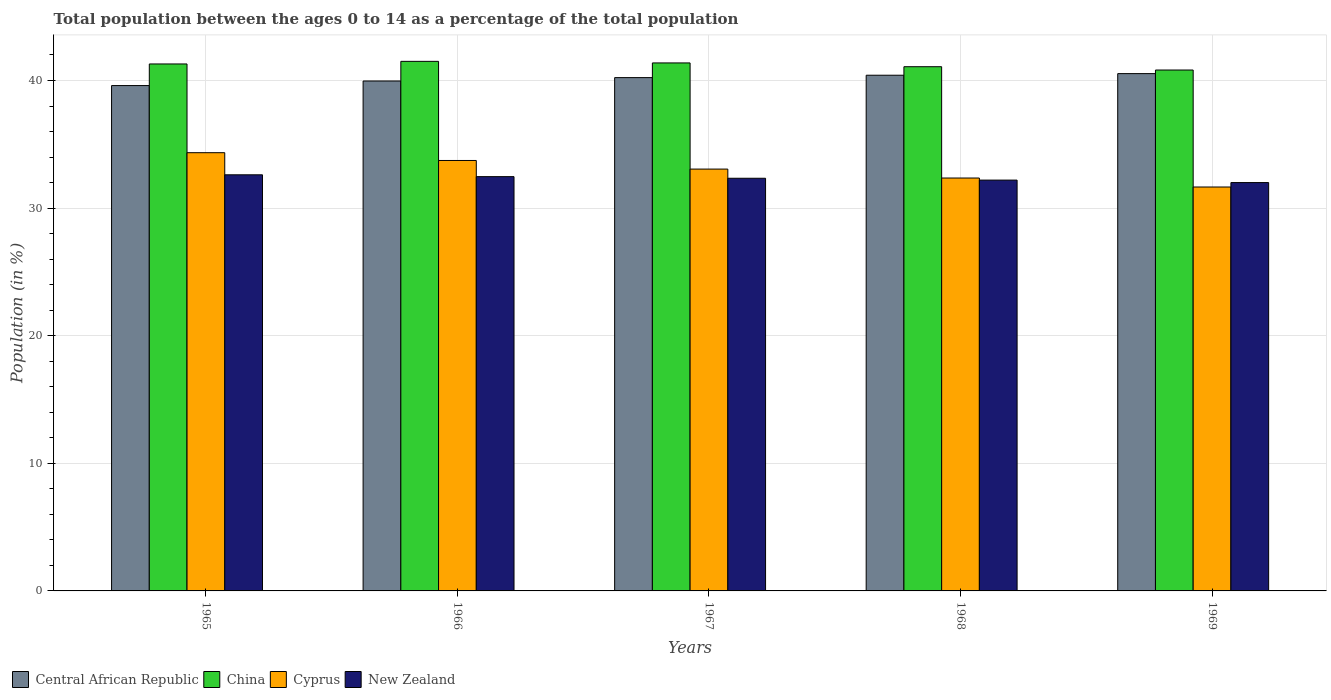Are the number of bars per tick equal to the number of legend labels?
Offer a terse response. Yes. Are the number of bars on each tick of the X-axis equal?
Provide a succinct answer. Yes. How many bars are there on the 2nd tick from the left?
Your response must be concise. 4. What is the label of the 3rd group of bars from the left?
Give a very brief answer. 1967. In how many cases, is the number of bars for a given year not equal to the number of legend labels?
Make the answer very short. 0. What is the percentage of the population ages 0 to 14 in China in 1968?
Your answer should be compact. 41.08. Across all years, what is the maximum percentage of the population ages 0 to 14 in Central African Republic?
Ensure brevity in your answer.  40.54. Across all years, what is the minimum percentage of the population ages 0 to 14 in Cyprus?
Your response must be concise. 31.65. In which year was the percentage of the population ages 0 to 14 in New Zealand maximum?
Keep it short and to the point. 1965. In which year was the percentage of the population ages 0 to 14 in Central African Republic minimum?
Keep it short and to the point. 1965. What is the total percentage of the population ages 0 to 14 in Central African Republic in the graph?
Provide a short and direct response. 200.74. What is the difference between the percentage of the population ages 0 to 14 in Cyprus in 1967 and that in 1968?
Ensure brevity in your answer.  0.7. What is the difference between the percentage of the population ages 0 to 14 in Cyprus in 1968 and the percentage of the population ages 0 to 14 in New Zealand in 1967?
Your response must be concise. 0.02. What is the average percentage of the population ages 0 to 14 in China per year?
Offer a very short reply. 41.22. In the year 1965, what is the difference between the percentage of the population ages 0 to 14 in New Zealand and percentage of the population ages 0 to 14 in Central African Republic?
Your response must be concise. -6.99. What is the ratio of the percentage of the population ages 0 to 14 in Cyprus in 1968 to that in 1969?
Ensure brevity in your answer.  1.02. Is the percentage of the population ages 0 to 14 in Central African Republic in 1966 less than that in 1969?
Offer a terse response. Yes. Is the difference between the percentage of the population ages 0 to 14 in New Zealand in 1966 and 1968 greater than the difference between the percentage of the population ages 0 to 14 in Central African Republic in 1966 and 1968?
Your response must be concise. Yes. What is the difference between the highest and the second highest percentage of the population ages 0 to 14 in Central African Republic?
Keep it short and to the point. 0.13. What is the difference between the highest and the lowest percentage of the population ages 0 to 14 in New Zealand?
Ensure brevity in your answer.  0.61. In how many years, is the percentage of the population ages 0 to 14 in Central African Republic greater than the average percentage of the population ages 0 to 14 in Central African Republic taken over all years?
Provide a short and direct response. 3. What does the 4th bar from the left in 1965 represents?
Ensure brevity in your answer.  New Zealand. What does the 4th bar from the right in 1967 represents?
Your answer should be very brief. Central African Republic. Is it the case that in every year, the sum of the percentage of the population ages 0 to 14 in Cyprus and percentage of the population ages 0 to 14 in New Zealand is greater than the percentage of the population ages 0 to 14 in China?
Your response must be concise. Yes. Are all the bars in the graph horizontal?
Your response must be concise. No. How many years are there in the graph?
Give a very brief answer. 5. What is the difference between two consecutive major ticks on the Y-axis?
Offer a terse response. 10. How many legend labels are there?
Keep it short and to the point. 4. How are the legend labels stacked?
Offer a very short reply. Horizontal. What is the title of the graph?
Make the answer very short. Total population between the ages 0 to 14 as a percentage of the total population. Does "Zambia" appear as one of the legend labels in the graph?
Your response must be concise. No. What is the label or title of the X-axis?
Make the answer very short. Years. What is the Population (in %) of Central African Republic in 1965?
Your answer should be compact. 39.6. What is the Population (in %) of China in 1965?
Your answer should be very brief. 41.3. What is the Population (in %) of Cyprus in 1965?
Offer a very short reply. 34.34. What is the Population (in %) in New Zealand in 1965?
Offer a terse response. 32.61. What is the Population (in %) of Central African Republic in 1966?
Make the answer very short. 39.96. What is the Population (in %) in China in 1966?
Make the answer very short. 41.5. What is the Population (in %) in Cyprus in 1966?
Keep it short and to the point. 33.73. What is the Population (in %) of New Zealand in 1966?
Your answer should be very brief. 32.47. What is the Population (in %) of Central African Republic in 1967?
Your answer should be very brief. 40.23. What is the Population (in %) in China in 1967?
Your response must be concise. 41.38. What is the Population (in %) in Cyprus in 1967?
Your answer should be compact. 33.06. What is the Population (in %) of New Zealand in 1967?
Provide a succinct answer. 32.34. What is the Population (in %) of Central African Republic in 1968?
Provide a succinct answer. 40.41. What is the Population (in %) in China in 1968?
Make the answer very short. 41.08. What is the Population (in %) of Cyprus in 1968?
Keep it short and to the point. 32.36. What is the Population (in %) in New Zealand in 1968?
Make the answer very short. 32.19. What is the Population (in %) of Central African Republic in 1969?
Your response must be concise. 40.54. What is the Population (in %) in China in 1969?
Your answer should be compact. 40.82. What is the Population (in %) of Cyprus in 1969?
Your response must be concise. 31.65. What is the Population (in %) in New Zealand in 1969?
Provide a short and direct response. 32. Across all years, what is the maximum Population (in %) of Central African Republic?
Your response must be concise. 40.54. Across all years, what is the maximum Population (in %) of China?
Make the answer very short. 41.5. Across all years, what is the maximum Population (in %) in Cyprus?
Offer a terse response. 34.34. Across all years, what is the maximum Population (in %) in New Zealand?
Offer a terse response. 32.61. Across all years, what is the minimum Population (in %) of Central African Republic?
Provide a short and direct response. 39.6. Across all years, what is the minimum Population (in %) in China?
Offer a terse response. 40.82. Across all years, what is the minimum Population (in %) of Cyprus?
Offer a terse response. 31.65. Across all years, what is the minimum Population (in %) in New Zealand?
Offer a terse response. 32. What is the total Population (in %) in Central African Republic in the graph?
Keep it short and to the point. 200.74. What is the total Population (in %) in China in the graph?
Your answer should be very brief. 206.08. What is the total Population (in %) of Cyprus in the graph?
Offer a terse response. 165.14. What is the total Population (in %) in New Zealand in the graph?
Your answer should be very brief. 161.61. What is the difference between the Population (in %) in Central African Republic in 1965 and that in 1966?
Your answer should be compact. -0.36. What is the difference between the Population (in %) in China in 1965 and that in 1966?
Offer a terse response. -0.2. What is the difference between the Population (in %) of Cyprus in 1965 and that in 1966?
Provide a short and direct response. 0.61. What is the difference between the Population (in %) in New Zealand in 1965 and that in 1966?
Give a very brief answer. 0.14. What is the difference between the Population (in %) of Central African Republic in 1965 and that in 1967?
Your answer should be compact. -0.62. What is the difference between the Population (in %) of China in 1965 and that in 1967?
Provide a short and direct response. -0.08. What is the difference between the Population (in %) in Cyprus in 1965 and that in 1967?
Offer a very short reply. 1.29. What is the difference between the Population (in %) in New Zealand in 1965 and that in 1967?
Provide a short and direct response. 0.27. What is the difference between the Population (in %) of Central African Republic in 1965 and that in 1968?
Provide a succinct answer. -0.81. What is the difference between the Population (in %) in China in 1965 and that in 1968?
Keep it short and to the point. 0.22. What is the difference between the Population (in %) of Cyprus in 1965 and that in 1968?
Your response must be concise. 1.99. What is the difference between the Population (in %) of New Zealand in 1965 and that in 1968?
Your answer should be very brief. 0.42. What is the difference between the Population (in %) in Central African Republic in 1965 and that in 1969?
Your answer should be very brief. -0.94. What is the difference between the Population (in %) of China in 1965 and that in 1969?
Offer a terse response. 0.48. What is the difference between the Population (in %) in Cyprus in 1965 and that in 1969?
Provide a short and direct response. 2.69. What is the difference between the Population (in %) of New Zealand in 1965 and that in 1969?
Your response must be concise. 0.61. What is the difference between the Population (in %) of Central African Republic in 1966 and that in 1967?
Offer a very short reply. -0.26. What is the difference between the Population (in %) in China in 1966 and that in 1967?
Give a very brief answer. 0.12. What is the difference between the Population (in %) of Cyprus in 1966 and that in 1967?
Your response must be concise. 0.68. What is the difference between the Population (in %) of New Zealand in 1966 and that in 1967?
Keep it short and to the point. 0.13. What is the difference between the Population (in %) of Central African Republic in 1966 and that in 1968?
Ensure brevity in your answer.  -0.45. What is the difference between the Population (in %) in China in 1966 and that in 1968?
Provide a succinct answer. 0.42. What is the difference between the Population (in %) of Cyprus in 1966 and that in 1968?
Make the answer very short. 1.38. What is the difference between the Population (in %) in New Zealand in 1966 and that in 1968?
Offer a very short reply. 0.27. What is the difference between the Population (in %) of Central African Republic in 1966 and that in 1969?
Offer a very short reply. -0.58. What is the difference between the Population (in %) of China in 1966 and that in 1969?
Your response must be concise. 0.68. What is the difference between the Population (in %) of Cyprus in 1966 and that in 1969?
Your answer should be very brief. 2.08. What is the difference between the Population (in %) of New Zealand in 1966 and that in 1969?
Your answer should be very brief. 0.46. What is the difference between the Population (in %) in Central African Republic in 1967 and that in 1968?
Your answer should be very brief. -0.19. What is the difference between the Population (in %) in China in 1967 and that in 1968?
Provide a short and direct response. 0.3. What is the difference between the Population (in %) in Cyprus in 1967 and that in 1968?
Your answer should be very brief. 0.7. What is the difference between the Population (in %) of New Zealand in 1967 and that in 1968?
Provide a succinct answer. 0.14. What is the difference between the Population (in %) in Central African Republic in 1967 and that in 1969?
Make the answer very short. -0.31. What is the difference between the Population (in %) of China in 1967 and that in 1969?
Your answer should be compact. 0.56. What is the difference between the Population (in %) of Cyprus in 1967 and that in 1969?
Provide a short and direct response. 1.4. What is the difference between the Population (in %) of New Zealand in 1967 and that in 1969?
Your answer should be compact. 0.34. What is the difference between the Population (in %) in Central African Republic in 1968 and that in 1969?
Keep it short and to the point. -0.13. What is the difference between the Population (in %) of China in 1968 and that in 1969?
Provide a short and direct response. 0.26. What is the difference between the Population (in %) of Cyprus in 1968 and that in 1969?
Offer a very short reply. 0.7. What is the difference between the Population (in %) of New Zealand in 1968 and that in 1969?
Your answer should be compact. 0.19. What is the difference between the Population (in %) of Central African Republic in 1965 and the Population (in %) of China in 1966?
Provide a succinct answer. -1.9. What is the difference between the Population (in %) of Central African Republic in 1965 and the Population (in %) of Cyprus in 1966?
Keep it short and to the point. 5.87. What is the difference between the Population (in %) of Central African Republic in 1965 and the Population (in %) of New Zealand in 1966?
Your response must be concise. 7.14. What is the difference between the Population (in %) in China in 1965 and the Population (in %) in Cyprus in 1966?
Offer a terse response. 7.56. What is the difference between the Population (in %) of China in 1965 and the Population (in %) of New Zealand in 1966?
Your answer should be compact. 8.83. What is the difference between the Population (in %) in Cyprus in 1965 and the Population (in %) in New Zealand in 1966?
Give a very brief answer. 1.88. What is the difference between the Population (in %) of Central African Republic in 1965 and the Population (in %) of China in 1967?
Provide a short and direct response. -1.77. What is the difference between the Population (in %) in Central African Republic in 1965 and the Population (in %) in Cyprus in 1967?
Offer a terse response. 6.55. What is the difference between the Population (in %) of Central African Republic in 1965 and the Population (in %) of New Zealand in 1967?
Make the answer very short. 7.26. What is the difference between the Population (in %) of China in 1965 and the Population (in %) of Cyprus in 1967?
Make the answer very short. 8.24. What is the difference between the Population (in %) in China in 1965 and the Population (in %) in New Zealand in 1967?
Your response must be concise. 8.96. What is the difference between the Population (in %) of Cyprus in 1965 and the Population (in %) of New Zealand in 1967?
Make the answer very short. 2. What is the difference between the Population (in %) of Central African Republic in 1965 and the Population (in %) of China in 1968?
Offer a terse response. -1.48. What is the difference between the Population (in %) of Central African Republic in 1965 and the Population (in %) of Cyprus in 1968?
Your answer should be compact. 7.25. What is the difference between the Population (in %) in Central African Republic in 1965 and the Population (in %) in New Zealand in 1968?
Your response must be concise. 7.41. What is the difference between the Population (in %) in China in 1965 and the Population (in %) in Cyprus in 1968?
Your response must be concise. 8.94. What is the difference between the Population (in %) of China in 1965 and the Population (in %) of New Zealand in 1968?
Ensure brevity in your answer.  9.1. What is the difference between the Population (in %) of Cyprus in 1965 and the Population (in %) of New Zealand in 1968?
Provide a succinct answer. 2.15. What is the difference between the Population (in %) in Central African Republic in 1965 and the Population (in %) in China in 1969?
Ensure brevity in your answer.  -1.22. What is the difference between the Population (in %) in Central African Republic in 1965 and the Population (in %) in Cyprus in 1969?
Your answer should be compact. 7.95. What is the difference between the Population (in %) in Central African Republic in 1965 and the Population (in %) in New Zealand in 1969?
Make the answer very short. 7.6. What is the difference between the Population (in %) in China in 1965 and the Population (in %) in Cyprus in 1969?
Give a very brief answer. 9.64. What is the difference between the Population (in %) of China in 1965 and the Population (in %) of New Zealand in 1969?
Your answer should be very brief. 9.3. What is the difference between the Population (in %) of Cyprus in 1965 and the Population (in %) of New Zealand in 1969?
Your answer should be very brief. 2.34. What is the difference between the Population (in %) of Central African Republic in 1966 and the Population (in %) of China in 1967?
Provide a succinct answer. -1.42. What is the difference between the Population (in %) of Central African Republic in 1966 and the Population (in %) of Cyprus in 1967?
Provide a succinct answer. 6.9. What is the difference between the Population (in %) in Central African Republic in 1966 and the Population (in %) in New Zealand in 1967?
Provide a short and direct response. 7.62. What is the difference between the Population (in %) in China in 1966 and the Population (in %) in Cyprus in 1967?
Give a very brief answer. 8.44. What is the difference between the Population (in %) in China in 1966 and the Population (in %) in New Zealand in 1967?
Make the answer very short. 9.16. What is the difference between the Population (in %) in Cyprus in 1966 and the Population (in %) in New Zealand in 1967?
Provide a succinct answer. 1.39. What is the difference between the Population (in %) in Central African Republic in 1966 and the Population (in %) in China in 1968?
Offer a terse response. -1.12. What is the difference between the Population (in %) in Central African Republic in 1966 and the Population (in %) in Cyprus in 1968?
Ensure brevity in your answer.  7.6. What is the difference between the Population (in %) in Central African Republic in 1966 and the Population (in %) in New Zealand in 1968?
Your response must be concise. 7.77. What is the difference between the Population (in %) of China in 1966 and the Population (in %) of Cyprus in 1968?
Make the answer very short. 9.14. What is the difference between the Population (in %) of China in 1966 and the Population (in %) of New Zealand in 1968?
Your answer should be compact. 9.31. What is the difference between the Population (in %) of Cyprus in 1966 and the Population (in %) of New Zealand in 1968?
Your response must be concise. 1.54. What is the difference between the Population (in %) of Central African Republic in 1966 and the Population (in %) of China in 1969?
Keep it short and to the point. -0.86. What is the difference between the Population (in %) in Central African Republic in 1966 and the Population (in %) in Cyprus in 1969?
Give a very brief answer. 8.31. What is the difference between the Population (in %) of Central African Republic in 1966 and the Population (in %) of New Zealand in 1969?
Your response must be concise. 7.96. What is the difference between the Population (in %) in China in 1966 and the Population (in %) in Cyprus in 1969?
Keep it short and to the point. 9.85. What is the difference between the Population (in %) in China in 1966 and the Population (in %) in New Zealand in 1969?
Ensure brevity in your answer.  9.5. What is the difference between the Population (in %) of Cyprus in 1966 and the Population (in %) of New Zealand in 1969?
Provide a short and direct response. 1.73. What is the difference between the Population (in %) of Central African Republic in 1967 and the Population (in %) of China in 1968?
Offer a terse response. -0.86. What is the difference between the Population (in %) in Central African Republic in 1967 and the Population (in %) in Cyprus in 1968?
Your answer should be compact. 7.87. What is the difference between the Population (in %) of Central African Republic in 1967 and the Population (in %) of New Zealand in 1968?
Provide a short and direct response. 8.03. What is the difference between the Population (in %) of China in 1967 and the Population (in %) of Cyprus in 1968?
Give a very brief answer. 9.02. What is the difference between the Population (in %) of China in 1967 and the Population (in %) of New Zealand in 1968?
Your answer should be very brief. 9.18. What is the difference between the Population (in %) in Cyprus in 1967 and the Population (in %) in New Zealand in 1968?
Ensure brevity in your answer.  0.86. What is the difference between the Population (in %) in Central African Republic in 1967 and the Population (in %) in China in 1969?
Keep it short and to the point. -0.59. What is the difference between the Population (in %) of Central African Republic in 1967 and the Population (in %) of Cyprus in 1969?
Provide a succinct answer. 8.57. What is the difference between the Population (in %) of Central African Republic in 1967 and the Population (in %) of New Zealand in 1969?
Provide a succinct answer. 8.22. What is the difference between the Population (in %) of China in 1967 and the Population (in %) of Cyprus in 1969?
Your answer should be compact. 9.72. What is the difference between the Population (in %) in China in 1967 and the Population (in %) in New Zealand in 1969?
Ensure brevity in your answer.  9.38. What is the difference between the Population (in %) of Cyprus in 1967 and the Population (in %) of New Zealand in 1969?
Your response must be concise. 1.06. What is the difference between the Population (in %) of Central African Republic in 1968 and the Population (in %) of China in 1969?
Your answer should be very brief. -0.41. What is the difference between the Population (in %) of Central African Republic in 1968 and the Population (in %) of Cyprus in 1969?
Offer a terse response. 8.76. What is the difference between the Population (in %) in Central African Republic in 1968 and the Population (in %) in New Zealand in 1969?
Give a very brief answer. 8.41. What is the difference between the Population (in %) in China in 1968 and the Population (in %) in Cyprus in 1969?
Give a very brief answer. 9.43. What is the difference between the Population (in %) in China in 1968 and the Population (in %) in New Zealand in 1969?
Offer a terse response. 9.08. What is the difference between the Population (in %) of Cyprus in 1968 and the Population (in %) of New Zealand in 1969?
Give a very brief answer. 0.36. What is the average Population (in %) of Central African Republic per year?
Ensure brevity in your answer.  40.15. What is the average Population (in %) of China per year?
Ensure brevity in your answer.  41.22. What is the average Population (in %) in Cyprus per year?
Offer a very short reply. 33.03. What is the average Population (in %) of New Zealand per year?
Provide a short and direct response. 32.32. In the year 1965, what is the difference between the Population (in %) of Central African Republic and Population (in %) of China?
Your answer should be very brief. -1.69. In the year 1965, what is the difference between the Population (in %) in Central African Republic and Population (in %) in Cyprus?
Give a very brief answer. 5.26. In the year 1965, what is the difference between the Population (in %) in Central African Republic and Population (in %) in New Zealand?
Ensure brevity in your answer.  6.99. In the year 1965, what is the difference between the Population (in %) of China and Population (in %) of Cyprus?
Offer a very short reply. 6.95. In the year 1965, what is the difference between the Population (in %) of China and Population (in %) of New Zealand?
Offer a very short reply. 8.69. In the year 1965, what is the difference between the Population (in %) in Cyprus and Population (in %) in New Zealand?
Provide a short and direct response. 1.73. In the year 1966, what is the difference between the Population (in %) in Central African Republic and Population (in %) in China?
Your answer should be very brief. -1.54. In the year 1966, what is the difference between the Population (in %) in Central African Republic and Population (in %) in Cyprus?
Your answer should be very brief. 6.23. In the year 1966, what is the difference between the Population (in %) in Central African Republic and Population (in %) in New Zealand?
Your answer should be compact. 7.5. In the year 1966, what is the difference between the Population (in %) in China and Population (in %) in Cyprus?
Keep it short and to the point. 7.77. In the year 1966, what is the difference between the Population (in %) in China and Population (in %) in New Zealand?
Ensure brevity in your answer.  9.03. In the year 1966, what is the difference between the Population (in %) of Cyprus and Population (in %) of New Zealand?
Keep it short and to the point. 1.27. In the year 1967, what is the difference between the Population (in %) of Central African Republic and Population (in %) of China?
Keep it short and to the point. -1.15. In the year 1967, what is the difference between the Population (in %) of Central African Republic and Population (in %) of Cyprus?
Give a very brief answer. 7.17. In the year 1967, what is the difference between the Population (in %) of Central African Republic and Population (in %) of New Zealand?
Provide a short and direct response. 7.89. In the year 1967, what is the difference between the Population (in %) of China and Population (in %) of Cyprus?
Ensure brevity in your answer.  8.32. In the year 1967, what is the difference between the Population (in %) in China and Population (in %) in New Zealand?
Ensure brevity in your answer.  9.04. In the year 1967, what is the difference between the Population (in %) in Cyprus and Population (in %) in New Zealand?
Make the answer very short. 0.72. In the year 1968, what is the difference between the Population (in %) of Central African Republic and Population (in %) of China?
Ensure brevity in your answer.  -0.67. In the year 1968, what is the difference between the Population (in %) of Central African Republic and Population (in %) of Cyprus?
Your response must be concise. 8.06. In the year 1968, what is the difference between the Population (in %) in Central African Republic and Population (in %) in New Zealand?
Provide a short and direct response. 8.22. In the year 1968, what is the difference between the Population (in %) of China and Population (in %) of Cyprus?
Your answer should be very brief. 8.72. In the year 1968, what is the difference between the Population (in %) of China and Population (in %) of New Zealand?
Give a very brief answer. 8.89. In the year 1968, what is the difference between the Population (in %) of Cyprus and Population (in %) of New Zealand?
Give a very brief answer. 0.16. In the year 1969, what is the difference between the Population (in %) in Central African Republic and Population (in %) in China?
Provide a short and direct response. -0.28. In the year 1969, what is the difference between the Population (in %) in Central African Republic and Population (in %) in Cyprus?
Make the answer very short. 8.89. In the year 1969, what is the difference between the Population (in %) in Central African Republic and Population (in %) in New Zealand?
Provide a succinct answer. 8.54. In the year 1969, what is the difference between the Population (in %) of China and Population (in %) of Cyprus?
Offer a very short reply. 9.17. In the year 1969, what is the difference between the Population (in %) of China and Population (in %) of New Zealand?
Your answer should be very brief. 8.82. In the year 1969, what is the difference between the Population (in %) in Cyprus and Population (in %) in New Zealand?
Your answer should be compact. -0.35. What is the ratio of the Population (in %) in China in 1965 to that in 1966?
Your answer should be very brief. 1. What is the ratio of the Population (in %) of Cyprus in 1965 to that in 1966?
Offer a very short reply. 1.02. What is the ratio of the Population (in %) in Central African Republic in 1965 to that in 1967?
Your answer should be very brief. 0.98. What is the ratio of the Population (in %) in Cyprus in 1965 to that in 1967?
Offer a terse response. 1.04. What is the ratio of the Population (in %) in New Zealand in 1965 to that in 1967?
Give a very brief answer. 1.01. What is the ratio of the Population (in %) of Central African Republic in 1965 to that in 1968?
Give a very brief answer. 0.98. What is the ratio of the Population (in %) in China in 1965 to that in 1968?
Your answer should be very brief. 1.01. What is the ratio of the Population (in %) of Cyprus in 1965 to that in 1968?
Make the answer very short. 1.06. What is the ratio of the Population (in %) of New Zealand in 1965 to that in 1968?
Your answer should be compact. 1.01. What is the ratio of the Population (in %) of Central African Republic in 1965 to that in 1969?
Offer a terse response. 0.98. What is the ratio of the Population (in %) of China in 1965 to that in 1969?
Your response must be concise. 1.01. What is the ratio of the Population (in %) of Cyprus in 1965 to that in 1969?
Provide a succinct answer. 1.08. What is the ratio of the Population (in %) of Central African Republic in 1966 to that in 1967?
Keep it short and to the point. 0.99. What is the ratio of the Population (in %) of China in 1966 to that in 1967?
Keep it short and to the point. 1. What is the ratio of the Population (in %) of Cyprus in 1966 to that in 1967?
Offer a very short reply. 1.02. What is the ratio of the Population (in %) in Central African Republic in 1966 to that in 1968?
Provide a succinct answer. 0.99. What is the ratio of the Population (in %) in China in 1966 to that in 1968?
Your answer should be very brief. 1.01. What is the ratio of the Population (in %) in Cyprus in 1966 to that in 1968?
Your answer should be compact. 1.04. What is the ratio of the Population (in %) of New Zealand in 1966 to that in 1968?
Provide a short and direct response. 1.01. What is the ratio of the Population (in %) of Central African Republic in 1966 to that in 1969?
Give a very brief answer. 0.99. What is the ratio of the Population (in %) in China in 1966 to that in 1969?
Provide a succinct answer. 1.02. What is the ratio of the Population (in %) of Cyprus in 1966 to that in 1969?
Give a very brief answer. 1.07. What is the ratio of the Population (in %) in New Zealand in 1966 to that in 1969?
Your response must be concise. 1.01. What is the ratio of the Population (in %) in Cyprus in 1967 to that in 1968?
Your response must be concise. 1.02. What is the ratio of the Population (in %) of New Zealand in 1967 to that in 1968?
Your answer should be very brief. 1. What is the ratio of the Population (in %) in China in 1967 to that in 1969?
Provide a short and direct response. 1.01. What is the ratio of the Population (in %) of Cyprus in 1967 to that in 1969?
Your response must be concise. 1.04. What is the ratio of the Population (in %) of New Zealand in 1967 to that in 1969?
Offer a terse response. 1.01. What is the ratio of the Population (in %) of Central African Republic in 1968 to that in 1969?
Provide a succinct answer. 1. What is the ratio of the Population (in %) in China in 1968 to that in 1969?
Your response must be concise. 1.01. What is the ratio of the Population (in %) of Cyprus in 1968 to that in 1969?
Your answer should be very brief. 1.02. What is the ratio of the Population (in %) of New Zealand in 1968 to that in 1969?
Provide a succinct answer. 1.01. What is the difference between the highest and the second highest Population (in %) of Central African Republic?
Offer a terse response. 0.13. What is the difference between the highest and the second highest Population (in %) of China?
Offer a terse response. 0.12. What is the difference between the highest and the second highest Population (in %) in Cyprus?
Provide a succinct answer. 0.61. What is the difference between the highest and the second highest Population (in %) in New Zealand?
Your answer should be very brief. 0.14. What is the difference between the highest and the lowest Population (in %) of Central African Republic?
Offer a very short reply. 0.94. What is the difference between the highest and the lowest Population (in %) of China?
Your response must be concise. 0.68. What is the difference between the highest and the lowest Population (in %) of Cyprus?
Keep it short and to the point. 2.69. What is the difference between the highest and the lowest Population (in %) of New Zealand?
Offer a very short reply. 0.61. 